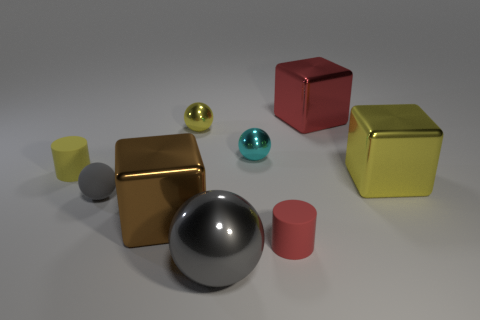Subtract 1 spheres. How many spheres are left? 3 Add 1 big brown metallic cylinders. How many objects exist? 10 Subtract all balls. How many objects are left? 5 Subtract all purple rubber cubes. Subtract all brown blocks. How many objects are left? 8 Add 8 big gray balls. How many big gray balls are left? 9 Add 1 tiny yellow cylinders. How many tiny yellow cylinders exist? 2 Subtract 1 cyan balls. How many objects are left? 8 